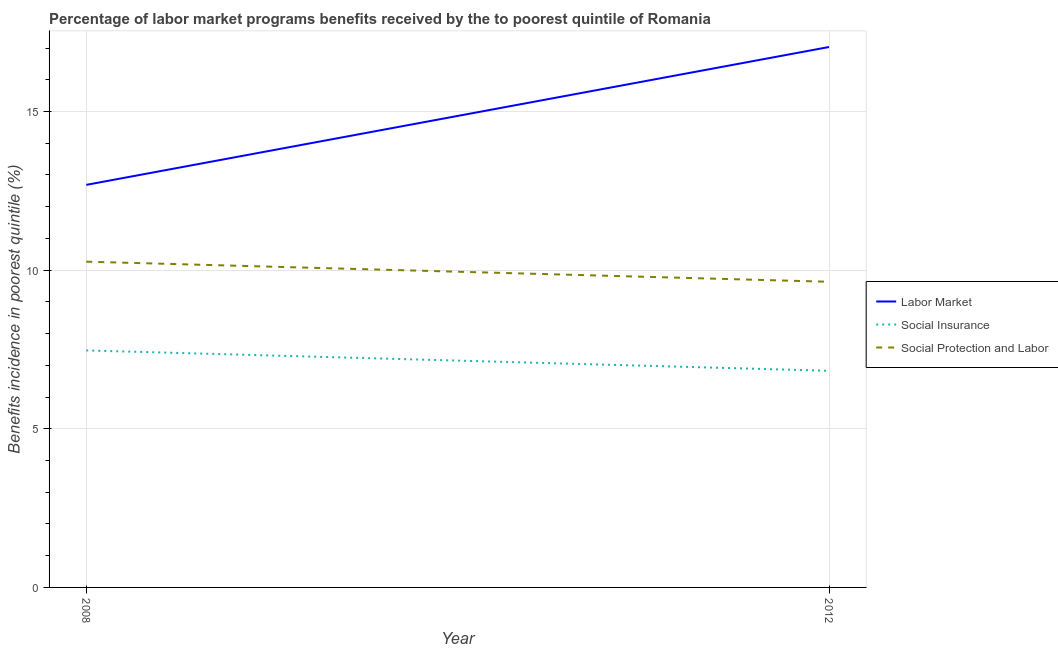How many different coloured lines are there?
Your answer should be compact. 3. What is the percentage of benefits received due to social protection programs in 2008?
Keep it short and to the point. 10.27. Across all years, what is the maximum percentage of benefits received due to social insurance programs?
Your response must be concise. 7.47. Across all years, what is the minimum percentage of benefits received due to social protection programs?
Offer a terse response. 9.63. What is the total percentage of benefits received due to social protection programs in the graph?
Ensure brevity in your answer.  19.9. What is the difference between the percentage of benefits received due to labor market programs in 2008 and that in 2012?
Your response must be concise. -4.35. What is the difference between the percentage of benefits received due to social protection programs in 2012 and the percentage of benefits received due to social insurance programs in 2008?
Offer a very short reply. 2.16. What is the average percentage of benefits received due to social protection programs per year?
Offer a very short reply. 9.95. In the year 2012, what is the difference between the percentage of benefits received due to social protection programs and percentage of benefits received due to social insurance programs?
Give a very brief answer. 2.81. What is the ratio of the percentage of benefits received due to social protection programs in 2008 to that in 2012?
Make the answer very short. 1.07. In how many years, is the percentage of benefits received due to social insurance programs greater than the average percentage of benefits received due to social insurance programs taken over all years?
Your response must be concise. 1. Does the percentage of benefits received due to labor market programs monotonically increase over the years?
Give a very brief answer. Yes. Is the percentage of benefits received due to social insurance programs strictly less than the percentage of benefits received due to social protection programs over the years?
Offer a terse response. Yes. How many years are there in the graph?
Give a very brief answer. 2. What is the difference between two consecutive major ticks on the Y-axis?
Make the answer very short. 5. Are the values on the major ticks of Y-axis written in scientific E-notation?
Provide a succinct answer. No. Where does the legend appear in the graph?
Make the answer very short. Center right. How many legend labels are there?
Your response must be concise. 3. What is the title of the graph?
Offer a terse response. Percentage of labor market programs benefits received by the to poorest quintile of Romania. What is the label or title of the X-axis?
Ensure brevity in your answer.  Year. What is the label or title of the Y-axis?
Your answer should be compact. Benefits incidence in poorest quintile (%). What is the Benefits incidence in poorest quintile (%) in Labor Market in 2008?
Provide a short and direct response. 12.69. What is the Benefits incidence in poorest quintile (%) in Social Insurance in 2008?
Offer a terse response. 7.47. What is the Benefits incidence in poorest quintile (%) in Social Protection and Labor in 2008?
Make the answer very short. 10.27. What is the Benefits incidence in poorest quintile (%) in Labor Market in 2012?
Provide a short and direct response. 17.03. What is the Benefits incidence in poorest quintile (%) of Social Insurance in 2012?
Provide a succinct answer. 6.83. What is the Benefits incidence in poorest quintile (%) of Social Protection and Labor in 2012?
Offer a terse response. 9.63. Across all years, what is the maximum Benefits incidence in poorest quintile (%) in Labor Market?
Offer a very short reply. 17.03. Across all years, what is the maximum Benefits incidence in poorest quintile (%) in Social Insurance?
Your response must be concise. 7.47. Across all years, what is the maximum Benefits incidence in poorest quintile (%) of Social Protection and Labor?
Your response must be concise. 10.27. Across all years, what is the minimum Benefits incidence in poorest quintile (%) in Labor Market?
Provide a short and direct response. 12.69. Across all years, what is the minimum Benefits incidence in poorest quintile (%) of Social Insurance?
Keep it short and to the point. 6.83. Across all years, what is the minimum Benefits incidence in poorest quintile (%) of Social Protection and Labor?
Offer a terse response. 9.63. What is the total Benefits incidence in poorest quintile (%) of Labor Market in the graph?
Provide a succinct answer. 29.72. What is the total Benefits incidence in poorest quintile (%) of Social Insurance in the graph?
Your answer should be very brief. 14.3. What is the total Benefits incidence in poorest quintile (%) of Social Protection and Labor in the graph?
Provide a short and direct response. 19.9. What is the difference between the Benefits incidence in poorest quintile (%) in Labor Market in 2008 and that in 2012?
Your answer should be compact. -4.35. What is the difference between the Benefits incidence in poorest quintile (%) of Social Insurance in 2008 and that in 2012?
Ensure brevity in your answer.  0.64. What is the difference between the Benefits incidence in poorest quintile (%) of Social Protection and Labor in 2008 and that in 2012?
Offer a very short reply. 0.63. What is the difference between the Benefits incidence in poorest quintile (%) of Labor Market in 2008 and the Benefits incidence in poorest quintile (%) of Social Insurance in 2012?
Offer a very short reply. 5.86. What is the difference between the Benefits incidence in poorest quintile (%) in Labor Market in 2008 and the Benefits incidence in poorest quintile (%) in Social Protection and Labor in 2012?
Your response must be concise. 3.05. What is the difference between the Benefits incidence in poorest quintile (%) of Social Insurance in 2008 and the Benefits incidence in poorest quintile (%) of Social Protection and Labor in 2012?
Keep it short and to the point. -2.16. What is the average Benefits incidence in poorest quintile (%) in Labor Market per year?
Make the answer very short. 14.86. What is the average Benefits incidence in poorest quintile (%) of Social Insurance per year?
Offer a terse response. 7.15. What is the average Benefits incidence in poorest quintile (%) of Social Protection and Labor per year?
Make the answer very short. 9.95. In the year 2008, what is the difference between the Benefits incidence in poorest quintile (%) in Labor Market and Benefits incidence in poorest quintile (%) in Social Insurance?
Provide a succinct answer. 5.22. In the year 2008, what is the difference between the Benefits incidence in poorest quintile (%) in Labor Market and Benefits incidence in poorest quintile (%) in Social Protection and Labor?
Your response must be concise. 2.42. In the year 2008, what is the difference between the Benefits incidence in poorest quintile (%) in Social Insurance and Benefits incidence in poorest quintile (%) in Social Protection and Labor?
Ensure brevity in your answer.  -2.8. In the year 2012, what is the difference between the Benefits incidence in poorest quintile (%) in Labor Market and Benefits incidence in poorest quintile (%) in Social Insurance?
Provide a succinct answer. 10.2. In the year 2012, what is the difference between the Benefits incidence in poorest quintile (%) in Labor Market and Benefits incidence in poorest quintile (%) in Social Protection and Labor?
Provide a short and direct response. 7.4. In the year 2012, what is the difference between the Benefits incidence in poorest quintile (%) in Social Insurance and Benefits incidence in poorest quintile (%) in Social Protection and Labor?
Give a very brief answer. -2.81. What is the ratio of the Benefits incidence in poorest quintile (%) in Labor Market in 2008 to that in 2012?
Your response must be concise. 0.74. What is the ratio of the Benefits incidence in poorest quintile (%) in Social Insurance in 2008 to that in 2012?
Give a very brief answer. 1.09. What is the ratio of the Benefits incidence in poorest quintile (%) in Social Protection and Labor in 2008 to that in 2012?
Offer a terse response. 1.07. What is the difference between the highest and the second highest Benefits incidence in poorest quintile (%) of Labor Market?
Keep it short and to the point. 4.35. What is the difference between the highest and the second highest Benefits incidence in poorest quintile (%) of Social Insurance?
Offer a very short reply. 0.64. What is the difference between the highest and the second highest Benefits incidence in poorest quintile (%) of Social Protection and Labor?
Your answer should be compact. 0.63. What is the difference between the highest and the lowest Benefits incidence in poorest quintile (%) in Labor Market?
Your response must be concise. 4.35. What is the difference between the highest and the lowest Benefits incidence in poorest quintile (%) of Social Insurance?
Keep it short and to the point. 0.64. What is the difference between the highest and the lowest Benefits incidence in poorest quintile (%) of Social Protection and Labor?
Give a very brief answer. 0.63. 